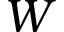<formula> <loc_0><loc_0><loc_500><loc_500>W</formula> 